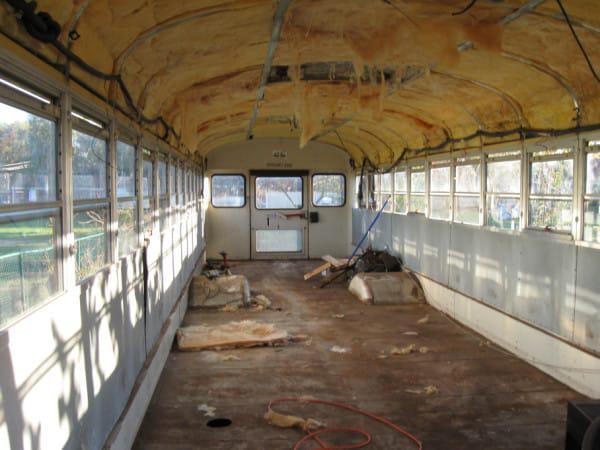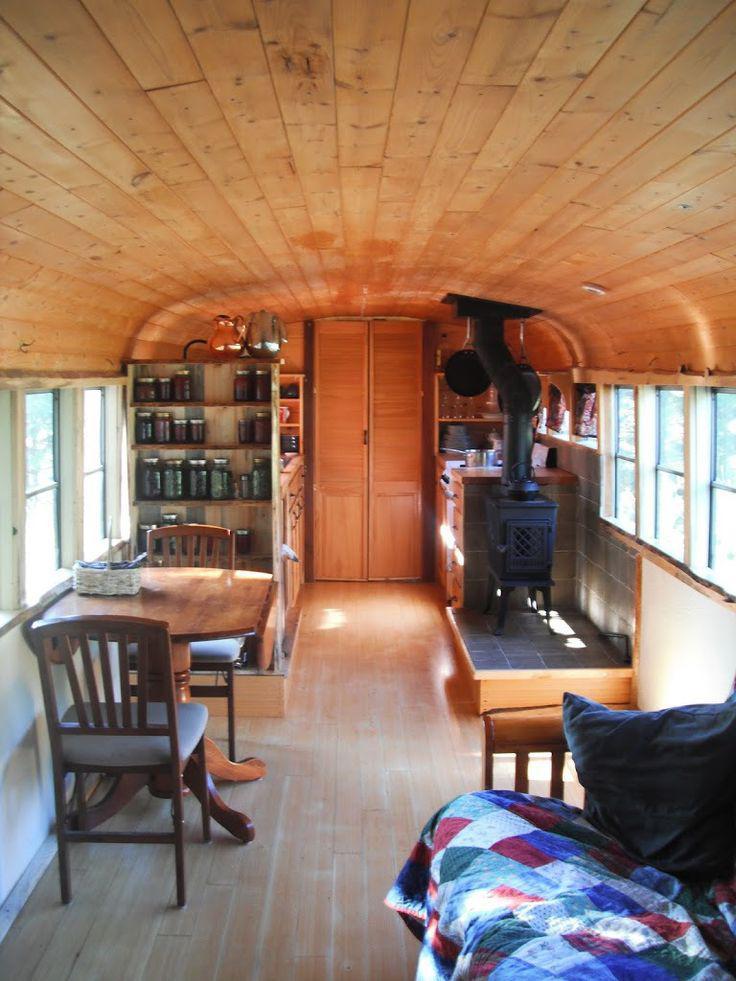The first image is the image on the left, the second image is the image on the right. Evaluate the accuracy of this statement regarding the images: "There is a small monitor in one of the images, but not the other". Is it true? Answer yes or no. No. 